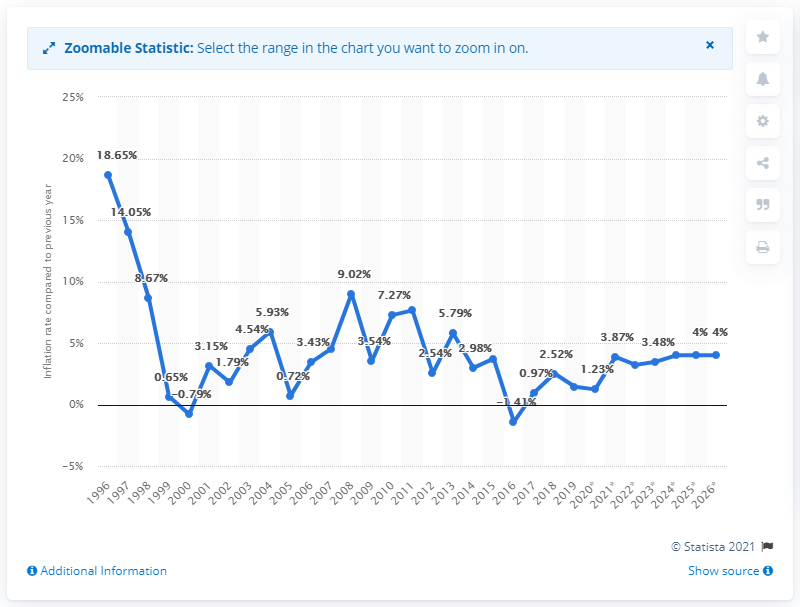Indicate a few pertinent items in this graphic. In 2019, Armenia's inflation rate was 1.44%. This is a decrease from the previous year, during which time the inflation rate was 9.83%. Despite this decrease, the inflation rate in Armenia remained relatively high in 2019, indicating that prices for goods and services were increasing at a steadily increasing rate. 